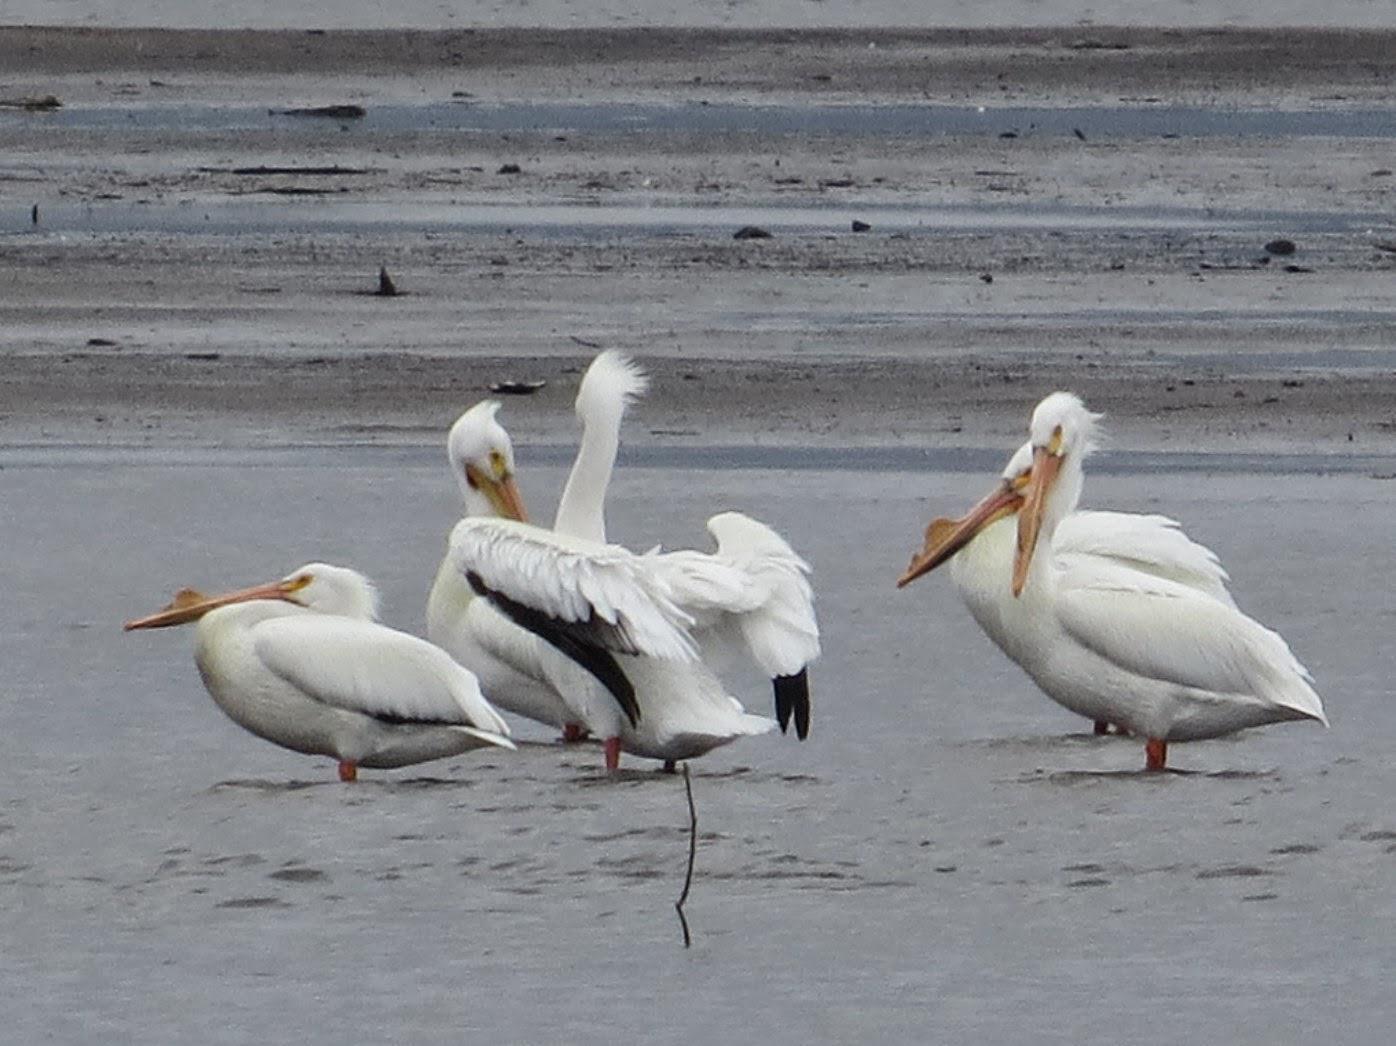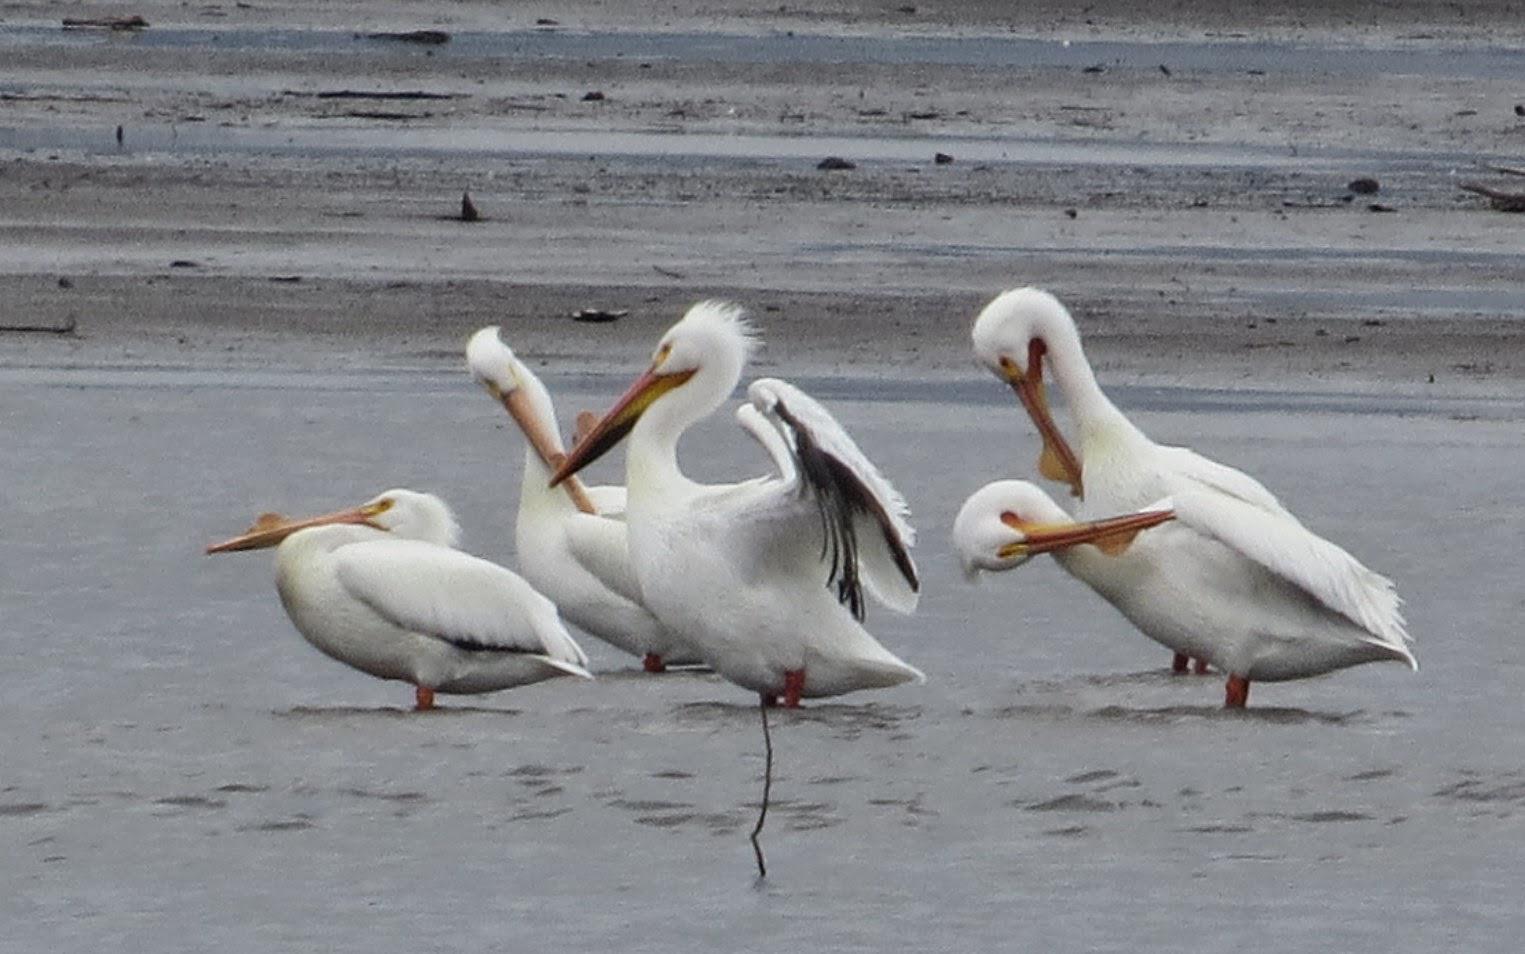The first image is the image on the left, the second image is the image on the right. Analyze the images presented: Is the assertion "The left image contains at least two large birds at a beach." valid? Answer yes or no. Yes. The first image is the image on the left, the second image is the image on the right. Evaluate the accuracy of this statement regarding the images: "One of the birds is spreading its wings.". Is it true? Answer yes or no. Yes. 